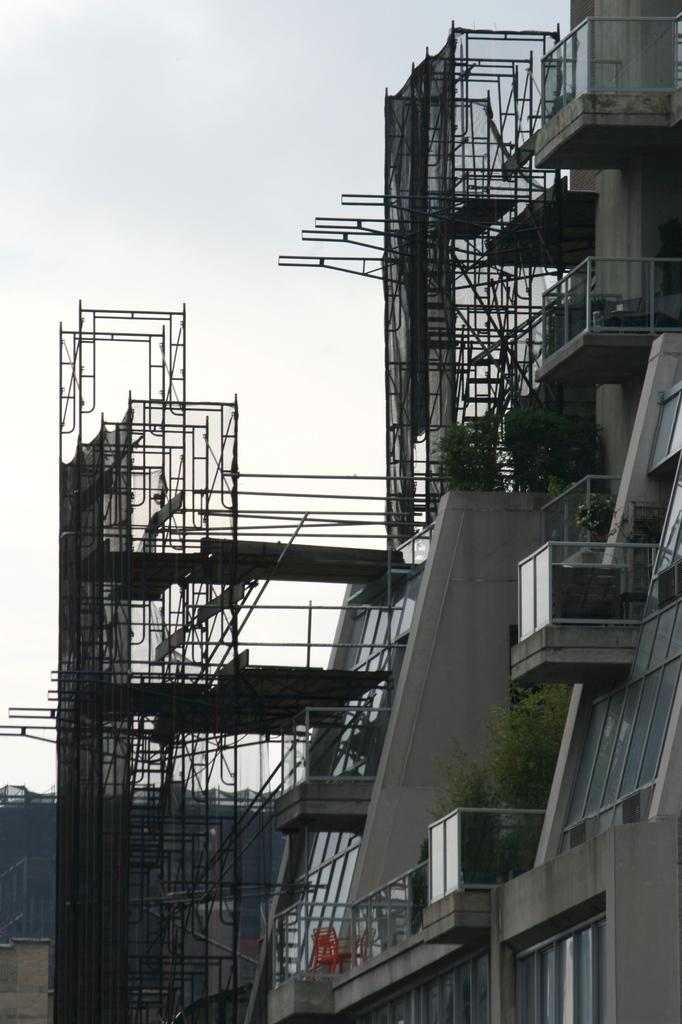What structure is located on the right side of the image? There is a building on the right side of the image. What is attached to the building? Advertising boards are attached to the building. What is visible at the top of the image? The sky is visible at the top of the image. What type of banana can be seen sliced on the advertising board? There is no banana present in the image, let alone a sliced one on the advertising board. 